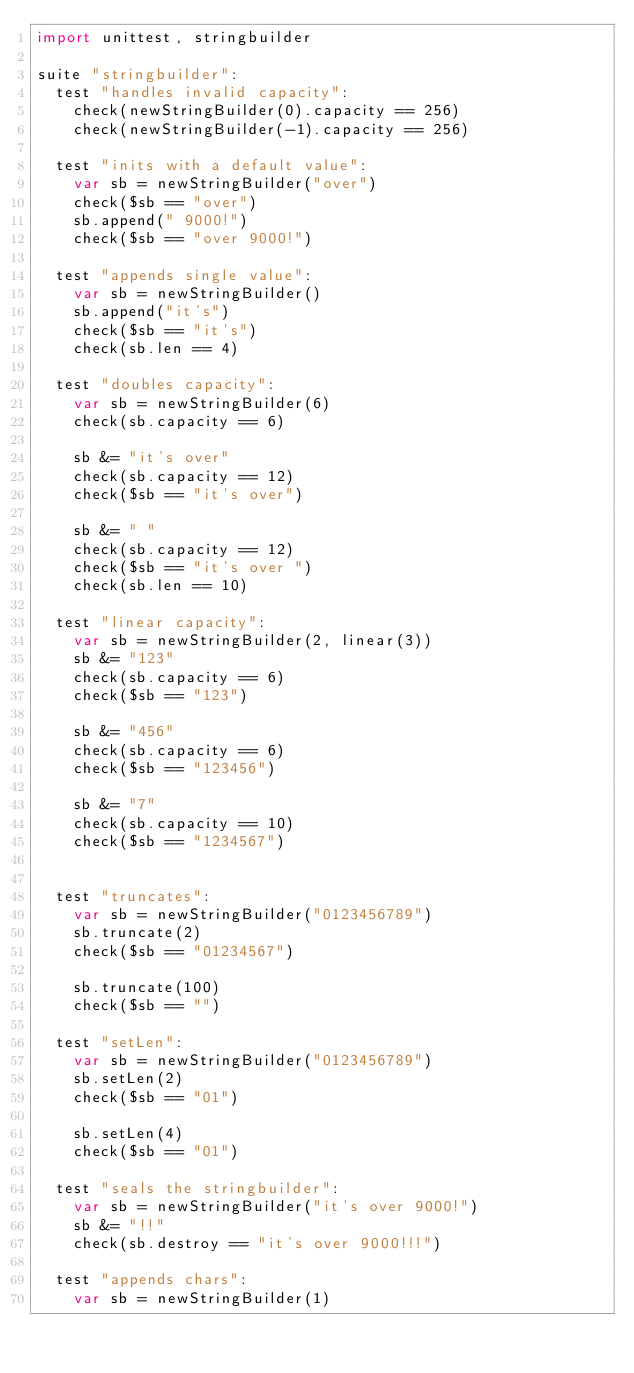Convert code to text. <code><loc_0><loc_0><loc_500><loc_500><_Nim_>import unittest, stringbuilder

suite "stringbuilder":
  test "handles invalid capacity":
    check(newStringBuilder(0).capacity == 256)
    check(newStringBuilder(-1).capacity == 256)

  test "inits with a default value":
    var sb = newStringBuilder("over")
    check($sb == "over")
    sb.append(" 9000!")
    check($sb == "over 9000!")

  test "appends single value":
    var sb = newStringBuilder()
    sb.append("it's")
    check($sb == "it's")
    check(sb.len == 4)

  test "doubles capacity":
    var sb = newStringBuilder(6)
    check(sb.capacity == 6)

    sb &= "it's over"
    check(sb.capacity == 12)
    check($sb == "it's over")

    sb &= " "
    check(sb.capacity == 12)
    check($sb == "it's over ")
    check(sb.len == 10)

  test "linear capacity":
    var sb = newStringBuilder(2, linear(3))
    sb &= "123"
    check(sb.capacity == 6)
    check($sb == "123")

    sb &= "456"
    check(sb.capacity == 6)
    check($sb == "123456")

    sb &= "7"
    check(sb.capacity == 10)
    check($sb == "1234567")


  test "truncates":
    var sb = newStringBuilder("0123456789")
    sb.truncate(2)
    check($sb == "01234567")

    sb.truncate(100)
    check($sb == "")

  test "setLen":
    var sb = newStringBuilder("0123456789")
    sb.setLen(2)
    check($sb == "01")

    sb.setLen(4)
    check($sb == "01")

  test "seals the stringbuilder":
    var sb = newStringBuilder("it's over 9000!")
    sb &= "!!"
    check(sb.destroy == "it's over 9000!!!")

  test "appends chars":
    var sb = newStringBuilder(1)</code> 